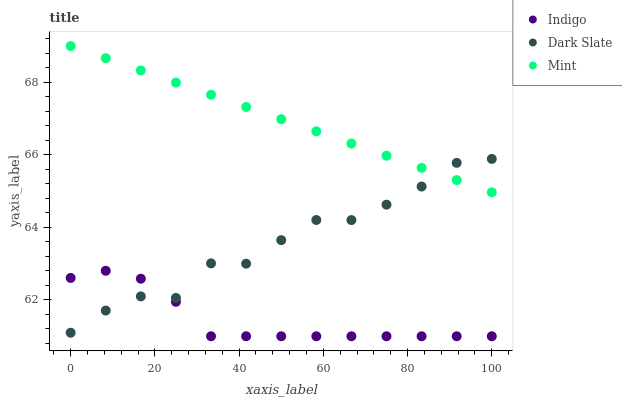Does Indigo have the minimum area under the curve?
Answer yes or no. Yes. Does Mint have the maximum area under the curve?
Answer yes or no. Yes. Does Mint have the minimum area under the curve?
Answer yes or no. No. Does Indigo have the maximum area under the curve?
Answer yes or no. No. Is Mint the smoothest?
Answer yes or no. Yes. Is Dark Slate the roughest?
Answer yes or no. Yes. Is Indigo the smoothest?
Answer yes or no. No. Is Indigo the roughest?
Answer yes or no. No. Does Indigo have the lowest value?
Answer yes or no. Yes. Does Mint have the lowest value?
Answer yes or no. No. Does Mint have the highest value?
Answer yes or no. Yes. Does Indigo have the highest value?
Answer yes or no. No. Is Indigo less than Mint?
Answer yes or no. Yes. Is Mint greater than Indigo?
Answer yes or no. Yes. Does Dark Slate intersect Mint?
Answer yes or no. Yes. Is Dark Slate less than Mint?
Answer yes or no. No. Is Dark Slate greater than Mint?
Answer yes or no. No. Does Indigo intersect Mint?
Answer yes or no. No. 